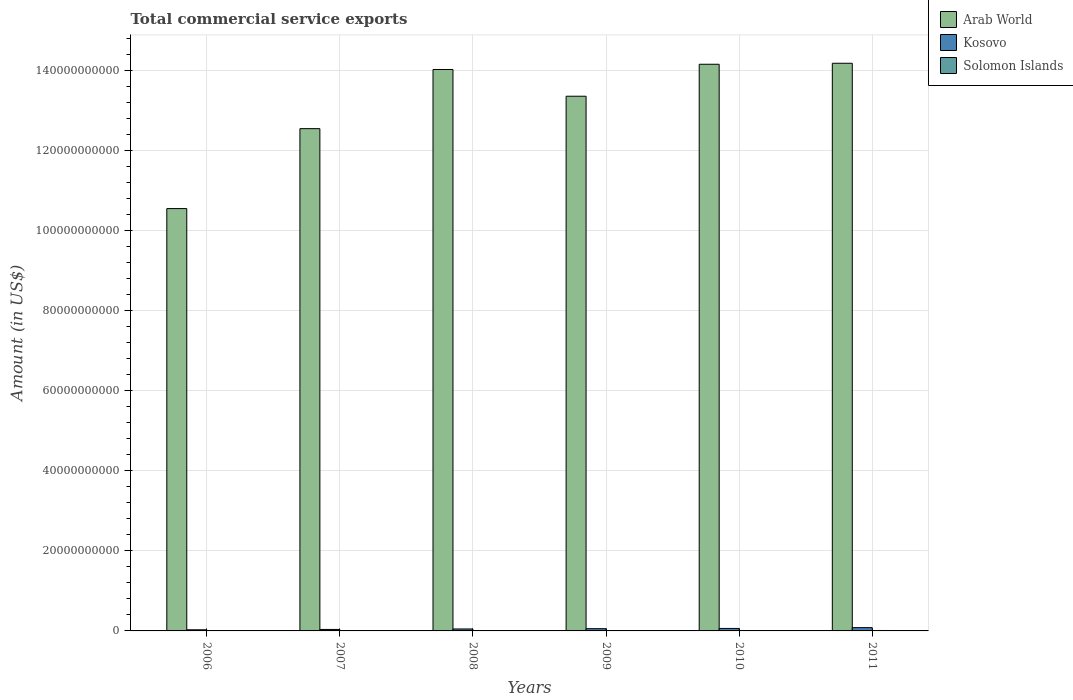Are the number of bars per tick equal to the number of legend labels?
Give a very brief answer. Yes. Are the number of bars on each tick of the X-axis equal?
Provide a short and direct response. Yes. How many bars are there on the 3rd tick from the left?
Your response must be concise. 3. How many bars are there on the 5th tick from the right?
Provide a short and direct response. 3. What is the label of the 2nd group of bars from the left?
Your answer should be very brief. 2007. What is the total commercial service exports in Solomon Islands in 2007?
Your response must be concise. 5.10e+07. Across all years, what is the maximum total commercial service exports in Arab World?
Provide a short and direct response. 1.42e+11. Across all years, what is the minimum total commercial service exports in Arab World?
Keep it short and to the point. 1.06e+11. In which year was the total commercial service exports in Solomon Islands maximum?
Your answer should be compact. 2011. In which year was the total commercial service exports in Kosovo minimum?
Your response must be concise. 2006. What is the total total commercial service exports in Arab World in the graph?
Provide a succinct answer. 7.89e+11. What is the difference between the total commercial service exports in Arab World in 2007 and that in 2008?
Your answer should be very brief. -1.48e+1. What is the difference between the total commercial service exports in Solomon Islands in 2007 and the total commercial service exports in Arab World in 2006?
Provide a short and direct response. -1.06e+11. What is the average total commercial service exports in Arab World per year?
Offer a terse response. 1.31e+11. In the year 2010, what is the difference between the total commercial service exports in Solomon Islands and total commercial service exports in Arab World?
Your answer should be very brief. -1.42e+11. What is the ratio of the total commercial service exports in Kosovo in 2008 to that in 2010?
Your answer should be compact. 0.79. What is the difference between the highest and the second highest total commercial service exports in Arab World?
Your response must be concise. 2.50e+08. What is the difference between the highest and the lowest total commercial service exports in Arab World?
Your answer should be compact. 3.63e+1. In how many years, is the total commercial service exports in Arab World greater than the average total commercial service exports in Arab World taken over all years?
Your answer should be very brief. 4. Is the sum of the total commercial service exports in Arab World in 2006 and 2008 greater than the maximum total commercial service exports in Solomon Islands across all years?
Offer a very short reply. Yes. What does the 2nd bar from the left in 2010 represents?
Your response must be concise. Kosovo. What does the 2nd bar from the right in 2007 represents?
Offer a terse response. Kosovo. What is the difference between two consecutive major ticks on the Y-axis?
Ensure brevity in your answer.  2.00e+1. Does the graph contain any zero values?
Offer a very short reply. No. How many legend labels are there?
Offer a terse response. 3. How are the legend labels stacked?
Offer a terse response. Vertical. What is the title of the graph?
Give a very brief answer. Total commercial service exports. What is the label or title of the Y-axis?
Keep it short and to the point. Amount (in US$). What is the Amount (in US$) in Arab World in 2006?
Give a very brief answer. 1.06e+11. What is the Amount (in US$) of Kosovo in 2006?
Provide a short and direct response. 2.84e+08. What is the Amount (in US$) of Solomon Islands in 2006?
Provide a short and direct response. 4.67e+07. What is the Amount (in US$) in Arab World in 2007?
Keep it short and to the point. 1.26e+11. What is the Amount (in US$) in Kosovo in 2007?
Ensure brevity in your answer.  3.71e+08. What is the Amount (in US$) of Solomon Islands in 2007?
Provide a short and direct response. 5.10e+07. What is the Amount (in US$) in Arab World in 2008?
Offer a terse response. 1.40e+11. What is the Amount (in US$) of Kosovo in 2008?
Your answer should be compact. 4.89e+08. What is the Amount (in US$) of Solomon Islands in 2008?
Offer a terse response. 4.44e+07. What is the Amount (in US$) of Arab World in 2009?
Your answer should be very brief. 1.34e+11. What is the Amount (in US$) in Kosovo in 2009?
Keep it short and to the point. 5.60e+08. What is the Amount (in US$) of Solomon Islands in 2009?
Ensure brevity in your answer.  5.53e+07. What is the Amount (in US$) of Arab World in 2010?
Your answer should be compact. 1.42e+11. What is the Amount (in US$) in Kosovo in 2010?
Offer a terse response. 6.21e+08. What is the Amount (in US$) in Solomon Islands in 2010?
Offer a very short reply. 8.93e+07. What is the Amount (in US$) in Arab World in 2011?
Make the answer very short. 1.42e+11. What is the Amount (in US$) of Kosovo in 2011?
Your answer should be very brief. 8.21e+08. What is the Amount (in US$) in Solomon Islands in 2011?
Your answer should be very brief. 1.08e+08. Across all years, what is the maximum Amount (in US$) of Arab World?
Your answer should be compact. 1.42e+11. Across all years, what is the maximum Amount (in US$) in Kosovo?
Your answer should be compact. 8.21e+08. Across all years, what is the maximum Amount (in US$) of Solomon Islands?
Make the answer very short. 1.08e+08. Across all years, what is the minimum Amount (in US$) of Arab World?
Keep it short and to the point. 1.06e+11. Across all years, what is the minimum Amount (in US$) in Kosovo?
Keep it short and to the point. 2.84e+08. Across all years, what is the minimum Amount (in US$) of Solomon Islands?
Provide a succinct answer. 4.44e+07. What is the total Amount (in US$) in Arab World in the graph?
Ensure brevity in your answer.  7.89e+11. What is the total Amount (in US$) in Kosovo in the graph?
Give a very brief answer. 3.15e+09. What is the total Amount (in US$) of Solomon Islands in the graph?
Offer a terse response. 3.95e+08. What is the difference between the Amount (in US$) in Arab World in 2006 and that in 2007?
Offer a very short reply. -2.00e+1. What is the difference between the Amount (in US$) of Kosovo in 2006 and that in 2007?
Your answer should be very brief. -8.64e+07. What is the difference between the Amount (in US$) in Solomon Islands in 2006 and that in 2007?
Provide a short and direct response. -4.36e+06. What is the difference between the Amount (in US$) in Arab World in 2006 and that in 2008?
Offer a very short reply. -3.48e+1. What is the difference between the Amount (in US$) of Kosovo in 2006 and that in 2008?
Ensure brevity in your answer.  -2.04e+08. What is the difference between the Amount (in US$) in Solomon Islands in 2006 and that in 2008?
Your response must be concise. 2.32e+06. What is the difference between the Amount (in US$) in Arab World in 2006 and that in 2009?
Ensure brevity in your answer.  -2.81e+1. What is the difference between the Amount (in US$) of Kosovo in 2006 and that in 2009?
Your answer should be compact. -2.76e+08. What is the difference between the Amount (in US$) of Solomon Islands in 2006 and that in 2009?
Make the answer very short. -8.57e+06. What is the difference between the Amount (in US$) of Arab World in 2006 and that in 2010?
Your response must be concise. -3.61e+1. What is the difference between the Amount (in US$) in Kosovo in 2006 and that in 2010?
Offer a very short reply. -3.37e+08. What is the difference between the Amount (in US$) in Solomon Islands in 2006 and that in 2010?
Offer a very short reply. -4.26e+07. What is the difference between the Amount (in US$) of Arab World in 2006 and that in 2011?
Offer a terse response. -3.63e+1. What is the difference between the Amount (in US$) of Kosovo in 2006 and that in 2011?
Give a very brief answer. -5.37e+08. What is the difference between the Amount (in US$) of Solomon Islands in 2006 and that in 2011?
Keep it short and to the point. -6.18e+07. What is the difference between the Amount (in US$) in Arab World in 2007 and that in 2008?
Ensure brevity in your answer.  -1.48e+1. What is the difference between the Amount (in US$) in Kosovo in 2007 and that in 2008?
Your response must be concise. -1.18e+08. What is the difference between the Amount (in US$) in Solomon Islands in 2007 and that in 2008?
Your response must be concise. 6.67e+06. What is the difference between the Amount (in US$) in Arab World in 2007 and that in 2009?
Keep it short and to the point. -8.11e+09. What is the difference between the Amount (in US$) in Kosovo in 2007 and that in 2009?
Offer a very short reply. -1.89e+08. What is the difference between the Amount (in US$) in Solomon Islands in 2007 and that in 2009?
Offer a very short reply. -4.21e+06. What is the difference between the Amount (in US$) in Arab World in 2007 and that in 2010?
Provide a short and direct response. -1.61e+1. What is the difference between the Amount (in US$) in Kosovo in 2007 and that in 2010?
Ensure brevity in your answer.  -2.50e+08. What is the difference between the Amount (in US$) in Solomon Islands in 2007 and that in 2010?
Your answer should be compact. -3.83e+07. What is the difference between the Amount (in US$) in Arab World in 2007 and that in 2011?
Offer a terse response. -1.63e+1. What is the difference between the Amount (in US$) in Kosovo in 2007 and that in 2011?
Give a very brief answer. -4.51e+08. What is the difference between the Amount (in US$) of Solomon Islands in 2007 and that in 2011?
Make the answer very short. -5.74e+07. What is the difference between the Amount (in US$) in Arab World in 2008 and that in 2009?
Give a very brief answer. 6.68e+09. What is the difference between the Amount (in US$) in Kosovo in 2008 and that in 2009?
Give a very brief answer. -7.14e+07. What is the difference between the Amount (in US$) in Solomon Islands in 2008 and that in 2009?
Your answer should be compact. -1.09e+07. What is the difference between the Amount (in US$) in Arab World in 2008 and that in 2010?
Offer a terse response. -1.31e+09. What is the difference between the Amount (in US$) in Kosovo in 2008 and that in 2010?
Give a very brief answer. -1.32e+08. What is the difference between the Amount (in US$) in Solomon Islands in 2008 and that in 2010?
Your answer should be compact. -4.49e+07. What is the difference between the Amount (in US$) in Arab World in 2008 and that in 2011?
Give a very brief answer. -1.56e+09. What is the difference between the Amount (in US$) in Kosovo in 2008 and that in 2011?
Offer a terse response. -3.33e+08. What is the difference between the Amount (in US$) of Solomon Islands in 2008 and that in 2011?
Make the answer very short. -6.41e+07. What is the difference between the Amount (in US$) of Arab World in 2009 and that in 2010?
Offer a terse response. -7.99e+09. What is the difference between the Amount (in US$) of Kosovo in 2009 and that in 2010?
Provide a succinct answer. -6.09e+07. What is the difference between the Amount (in US$) of Solomon Islands in 2009 and that in 2010?
Provide a succinct answer. -3.41e+07. What is the difference between the Amount (in US$) of Arab World in 2009 and that in 2011?
Ensure brevity in your answer.  -8.24e+09. What is the difference between the Amount (in US$) in Kosovo in 2009 and that in 2011?
Keep it short and to the point. -2.61e+08. What is the difference between the Amount (in US$) of Solomon Islands in 2009 and that in 2011?
Provide a succinct answer. -5.32e+07. What is the difference between the Amount (in US$) in Arab World in 2010 and that in 2011?
Keep it short and to the point. -2.50e+08. What is the difference between the Amount (in US$) of Kosovo in 2010 and that in 2011?
Offer a very short reply. -2.00e+08. What is the difference between the Amount (in US$) of Solomon Islands in 2010 and that in 2011?
Offer a terse response. -1.91e+07. What is the difference between the Amount (in US$) of Arab World in 2006 and the Amount (in US$) of Kosovo in 2007?
Make the answer very short. 1.05e+11. What is the difference between the Amount (in US$) of Arab World in 2006 and the Amount (in US$) of Solomon Islands in 2007?
Offer a terse response. 1.06e+11. What is the difference between the Amount (in US$) of Kosovo in 2006 and the Amount (in US$) of Solomon Islands in 2007?
Your answer should be compact. 2.33e+08. What is the difference between the Amount (in US$) in Arab World in 2006 and the Amount (in US$) in Kosovo in 2008?
Make the answer very short. 1.05e+11. What is the difference between the Amount (in US$) of Arab World in 2006 and the Amount (in US$) of Solomon Islands in 2008?
Your answer should be very brief. 1.06e+11. What is the difference between the Amount (in US$) of Kosovo in 2006 and the Amount (in US$) of Solomon Islands in 2008?
Your answer should be very brief. 2.40e+08. What is the difference between the Amount (in US$) of Arab World in 2006 and the Amount (in US$) of Kosovo in 2009?
Ensure brevity in your answer.  1.05e+11. What is the difference between the Amount (in US$) in Arab World in 2006 and the Amount (in US$) in Solomon Islands in 2009?
Keep it short and to the point. 1.06e+11. What is the difference between the Amount (in US$) of Kosovo in 2006 and the Amount (in US$) of Solomon Islands in 2009?
Provide a short and direct response. 2.29e+08. What is the difference between the Amount (in US$) in Arab World in 2006 and the Amount (in US$) in Kosovo in 2010?
Your answer should be compact. 1.05e+11. What is the difference between the Amount (in US$) in Arab World in 2006 and the Amount (in US$) in Solomon Islands in 2010?
Provide a succinct answer. 1.05e+11. What is the difference between the Amount (in US$) in Kosovo in 2006 and the Amount (in US$) in Solomon Islands in 2010?
Your response must be concise. 1.95e+08. What is the difference between the Amount (in US$) of Arab World in 2006 and the Amount (in US$) of Kosovo in 2011?
Provide a short and direct response. 1.05e+11. What is the difference between the Amount (in US$) of Arab World in 2006 and the Amount (in US$) of Solomon Islands in 2011?
Ensure brevity in your answer.  1.05e+11. What is the difference between the Amount (in US$) of Kosovo in 2006 and the Amount (in US$) of Solomon Islands in 2011?
Make the answer very short. 1.76e+08. What is the difference between the Amount (in US$) of Arab World in 2007 and the Amount (in US$) of Kosovo in 2008?
Provide a succinct answer. 1.25e+11. What is the difference between the Amount (in US$) of Arab World in 2007 and the Amount (in US$) of Solomon Islands in 2008?
Keep it short and to the point. 1.26e+11. What is the difference between the Amount (in US$) in Kosovo in 2007 and the Amount (in US$) in Solomon Islands in 2008?
Give a very brief answer. 3.26e+08. What is the difference between the Amount (in US$) in Arab World in 2007 and the Amount (in US$) in Kosovo in 2009?
Your answer should be compact. 1.25e+11. What is the difference between the Amount (in US$) in Arab World in 2007 and the Amount (in US$) in Solomon Islands in 2009?
Make the answer very short. 1.26e+11. What is the difference between the Amount (in US$) of Kosovo in 2007 and the Amount (in US$) of Solomon Islands in 2009?
Offer a very short reply. 3.15e+08. What is the difference between the Amount (in US$) of Arab World in 2007 and the Amount (in US$) of Kosovo in 2010?
Offer a very short reply. 1.25e+11. What is the difference between the Amount (in US$) in Arab World in 2007 and the Amount (in US$) in Solomon Islands in 2010?
Keep it short and to the point. 1.25e+11. What is the difference between the Amount (in US$) in Kosovo in 2007 and the Amount (in US$) in Solomon Islands in 2010?
Offer a terse response. 2.81e+08. What is the difference between the Amount (in US$) in Arab World in 2007 and the Amount (in US$) in Kosovo in 2011?
Keep it short and to the point. 1.25e+11. What is the difference between the Amount (in US$) in Arab World in 2007 and the Amount (in US$) in Solomon Islands in 2011?
Your answer should be very brief. 1.25e+11. What is the difference between the Amount (in US$) of Kosovo in 2007 and the Amount (in US$) of Solomon Islands in 2011?
Your answer should be compact. 2.62e+08. What is the difference between the Amount (in US$) in Arab World in 2008 and the Amount (in US$) in Kosovo in 2009?
Give a very brief answer. 1.40e+11. What is the difference between the Amount (in US$) in Arab World in 2008 and the Amount (in US$) in Solomon Islands in 2009?
Keep it short and to the point. 1.40e+11. What is the difference between the Amount (in US$) of Kosovo in 2008 and the Amount (in US$) of Solomon Islands in 2009?
Provide a succinct answer. 4.33e+08. What is the difference between the Amount (in US$) in Arab World in 2008 and the Amount (in US$) in Kosovo in 2010?
Provide a succinct answer. 1.40e+11. What is the difference between the Amount (in US$) in Arab World in 2008 and the Amount (in US$) in Solomon Islands in 2010?
Provide a succinct answer. 1.40e+11. What is the difference between the Amount (in US$) of Kosovo in 2008 and the Amount (in US$) of Solomon Islands in 2010?
Offer a terse response. 3.99e+08. What is the difference between the Amount (in US$) of Arab World in 2008 and the Amount (in US$) of Kosovo in 2011?
Provide a short and direct response. 1.40e+11. What is the difference between the Amount (in US$) in Arab World in 2008 and the Amount (in US$) in Solomon Islands in 2011?
Ensure brevity in your answer.  1.40e+11. What is the difference between the Amount (in US$) of Kosovo in 2008 and the Amount (in US$) of Solomon Islands in 2011?
Offer a terse response. 3.80e+08. What is the difference between the Amount (in US$) in Arab World in 2009 and the Amount (in US$) in Kosovo in 2010?
Your answer should be very brief. 1.33e+11. What is the difference between the Amount (in US$) of Arab World in 2009 and the Amount (in US$) of Solomon Islands in 2010?
Give a very brief answer. 1.34e+11. What is the difference between the Amount (in US$) in Kosovo in 2009 and the Amount (in US$) in Solomon Islands in 2010?
Provide a succinct answer. 4.71e+08. What is the difference between the Amount (in US$) in Arab World in 2009 and the Amount (in US$) in Kosovo in 2011?
Offer a very short reply. 1.33e+11. What is the difference between the Amount (in US$) in Arab World in 2009 and the Amount (in US$) in Solomon Islands in 2011?
Your answer should be very brief. 1.34e+11. What is the difference between the Amount (in US$) of Kosovo in 2009 and the Amount (in US$) of Solomon Islands in 2011?
Provide a short and direct response. 4.51e+08. What is the difference between the Amount (in US$) in Arab World in 2010 and the Amount (in US$) in Kosovo in 2011?
Give a very brief answer. 1.41e+11. What is the difference between the Amount (in US$) in Arab World in 2010 and the Amount (in US$) in Solomon Islands in 2011?
Your answer should be very brief. 1.42e+11. What is the difference between the Amount (in US$) in Kosovo in 2010 and the Amount (in US$) in Solomon Islands in 2011?
Make the answer very short. 5.12e+08. What is the average Amount (in US$) of Arab World per year?
Give a very brief answer. 1.31e+11. What is the average Amount (in US$) in Kosovo per year?
Make the answer very short. 5.24e+08. What is the average Amount (in US$) in Solomon Islands per year?
Make the answer very short. 6.59e+07. In the year 2006, what is the difference between the Amount (in US$) in Arab World and Amount (in US$) in Kosovo?
Provide a succinct answer. 1.05e+11. In the year 2006, what is the difference between the Amount (in US$) of Arab World and Amount (in US$) of Solomon Islands?
Your answer should be compact. 1.06e+11. In the year 2006, what is the difference between the Amount (in US$) of Kosovo and Amount (in US$) of Solomon Islands?
Your response must be concise. 2.37e+08. In the year 2007, what is the difference between the Amount (in US$) in Arab World and Amount (in US$) in Kosovo?
Your answer should be very brief. 1.25e+11. In the year 2007, what is the difference between the Amount (in US$) in Arab World and Amount (in US$) in Solomon Islands?
Provide a succinct answer. 1.26e+11. In the year 2007, what is the difference between the Amount (in US$) in Kosovo and Amount (in US$) in Solomon Islands?
Your answer should be very brief. 3.19e+08. In the year 2008, what is the difference between the Amount (in US$) in Arab World and Amount (in US$) in Kosovo?
Your response must be concise. 1.40e+11. In the year 2008, what is the difference between the Amount (in US$) of Arab World and Amount (in US$) of Solomon Islands?
Give a very brief answer. 1.40e+11. In the year 2008, what is the difference between the Amount (in US$) in Kosovo and Amount (in US$) in Solomon Islands?
Offer a terse response. 4.44e+08. In the year 2009, what is the difference between the Amount (in US$) of Arab World and Amount (in US$) of Kosovo?
Give a very brief answer. 1.33e+11. In the year 2009, what is the difference between the Amount (in US$) of Arab World and Amount (in US$) of Solomon Islands?
Your answer should be very brief. 1.34e+11. In the year 2009, what is the difference between the Amount (in US$) of Kosovo and Amount (in US$) of Solomon Islands?
Your answer should be compact. 5.05e+08. In the year 2010, what is the difference between the Amount (in US$) in Arab World and Amount (in US$) in Kosovo?
Provide a succinct answer. 1.41e+11. In the year 2010, what is the difference between the Amount (in US$) in Arab World and Amount (in US$) in Solomon Islands?
Provide a succinct answer. 1.42e+11. In the year 2010, what is the difference between the Amount (in US$) in Kosovo and Amount (in US$) in Solomon Islands?
Your answer should be very brief. 5.32e+08. In the year 2011, what is the difference between the Amount (in US$) in Arab World and Amount (in US$) in Kosovo?
Your answer should be very brief. 1.41e+11. In the year 2011, what is the difference between the Amount (in US$) of Arab World and Amount (in US$) of Solomon Islands?
Ensure brevity in your answer.  1.42e+11. In the year 2011, what is the difference between the Amount (in US$) in Kosovo and Amount (in US$) in Solomon Islands?
Ensure brevity in your answer.  7.13e+08. What is the ratio of the Amount (in US$) in Arab World in 2006 to that in 2007?
Your answer should be very brief. 0.84. What is the ratio of the Amount (in US$) in Kosovo in 2006 to that in 2007?
Keep it short and to the point. 0.77. What is the ratio of the Amount (in US$) in Solomon Islands in 2006 to that in 2007?
Your answer should be very brief. 0.91. What is the ratio of the Amount (in US$) of Arab World in 2006 to that in 2008?
Make the answer very short. 0.75. What is the ratio of the Amount (in US$) of Kosovo in 2006 to that in 2008?
Offer a very short reply. 0.58. What is the ratio of the Amount (in US$) of Solomon Islands in 2006 to that in 2008?
Give a very brief answer. 1.05. What is the ratio of the Amount (in US$) of Arab World in 2006 to that in 2009?
Provide a succinct answer. 0.79. What is the ratio of the Amount (in US$) of Kosovo in 2006 to that in 2009?
Keep it short and to the point. 0.51. What is the ratio of the Amount (in US$) of Solomon Islands in 2006 to that in 2009?
Make the answer very short. 0.84. What is the ratio of the Amount (in US$) in Arab World in 2006 to that in 2010?
Give a very brief answer. 0.75. What is the ratio of the Amount (in US$) in Kosovo in 2006 to that in 2010?
Offer a very short reply. 0.46. What is the ratio of the Amount (in US$) of Solomon Islands in 2006 to that in 2010?
Provide a short and direct response. 0.52. What is the ratio of the Amount (in US$) in Arab World in 2006 to that in 2011?
Your answer should be compact. 0.74. What is the ratio of the Amount (in US$) of Kosovo in 2006 to that in 2011?
Offer a very short reply. 0.35. What is the ratio of the Amount (in US$) in Solomon Islands in 2006 to that in 2011?
Provide a short and direct response. 0.43. What is the ratio of the Amount (in US$) in Arab World in 2007 to that in 2008?
Offer a terse response. 0.89. What is the ratio of the Amount (in US$) of Kosovo in 2007 to that in 2008?
Ensure brevity in your answer.  0.76. What is the ratio of the Amount (in US$) of Solomon Islands in 2007 to that in 2008?
Make the answer very short. 1.15. What is the ratio of the Amount (in US$) of Arab World in 2007 to that in 2009?
Make the answer very short. 0.94. What is the ratio of the Amount (in US$) in Kosovo in 2007 to that in 2009?
Your response must be concise. 0.66. What is the ratio of the Amount (in US$) of Solomon Islands in 2007 to that in 2009?
Ensure brevity in your answer.  0.92. What is the ratio of the Amount (in US$) of Arab World in 2007 to that in 2010?
Keep it short and to the point. 0.89. What is the ratio of the Amount (in US$) of Kosovo in 2007 to that in 2010?
Give a very brief answer. 0.6. What is the ratio of the Amount (in US$) of Solomon Islands in 2007 to that in 2010?
Make the answer very short. 0.57. What is the ratio of the Amount (in US$) of Arab World in 2007 to that in 2011?
Keep it short and to the point. 0.88. What is the ratio of the Amount (in US$) in Kosovo in 2007 to that in 2011?
Your answer should be compact. 0.45. What is the ratio of the Amount (in US$) in Solomon Islands in 2007 to that in 2011?
Provide a short and direct response. 0.47. What is the ratio of the Amount (in US$) in Kosovo in 2008 to that in 2009?
Provide a succinct answer. 0.87. What is the ratio of the Amount (in US$) of Solomon Islands in 2008 to that in 2009?
Keep it short and to the point. 0.8. What is the ratio of the Amount (in US$) of Arab World in 2008 to that in 2010?
Your answer should be compact. 0.99. What is the ratio of the Amount (in US$) in Kosovo in 2008 to that in 2010?
Your answer should be compact. 0.79. What is the ratio of the Amount (in US$) in Solomon Islands in 2008 to that in 2010?
Your answer should be very brief. 0.5. What is the ratio of the Amount (in US$) of Arab World in 2008 to that in 2011?
Your response must be concise. 0.99. What is the ratio of the Amount (in US$) in Kosovo in 2008 to that in 2011?
Ensure brevity in your answer.  0.59. What is the ratio of the Amount (in US$) in Solomon Islands in 2008 to that in 2011?
Your answer should be very brief. 0.41. What is the ratio of the Amount (in US$) in Arab World in 2009 to that in 2010?
Your answer should be compact. 0.94. What is the ratio of the Amount (in US$) of Kosovo in 2009 to that in 2010?
Give a very brief answer. 0.9. What is the ratio of the Amount (in US$) of Solomon Islands in 2009 to that in 2010?
Your response must be concise. 0.62. What is the ratio of the Amount (in US$) of Arab World in 2009 to that in 2011?
Make the answer very short. 0.94. What is the ratio of the Amount (in US$) of Kosovo in 2009 to that in 2011?
Offer a very short reply. 0.68. What is the ratio of the Amount (in US$) in Solomon Islands in 2009 to that in 2011?
Keep it short and to the point. 0.51. What is the ratio of the Amount (in US$) in Arab World in 2010 to that in 2011?
Offer a very short reply. 1. What is the ratio of the Amount (in US$) of Kosovo in 2010 to that in 2011?
Keep it short and to the point. 0.76. What is the ratio of the Amount (in US$) of Solomon Islands in 2010 to that in 2011?
Offer a very short reply. 0.82. What is the difference between the highest and the second highest Amount (in US$) of Arab World?
Ensure brevity in your answer.  2.50e+08. What is the difference between the highest and the second highest Amount (in US$) in Kosovo?
Provide a short and direct response. 2.00e+08. What is the difference between the highest and the second highest Amount (in US$) of Solomon Islands?
Keep it short and to the point. 1.91e+07. What is the difference between the highest and the lowest Amount (in US$) of Arab World?
Keep it short and to the point. 3.63e+1. What is the difference between the highest and the lowest Amount (in US$) in Kosovo?
Provide a short and direct response. 5.37e+08. What is the difference between the highest and the lowest Amount (in US$) in Solomon Islands?
Give a very brief answer. 6.41e+07. 